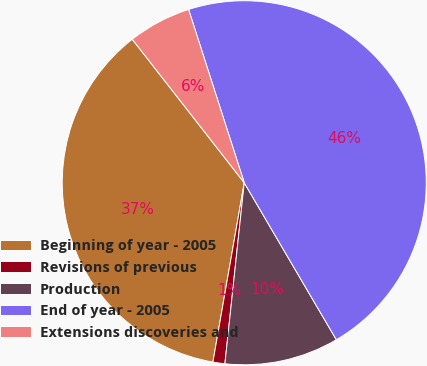<chart> <loc_0><loc_0><loc_500><loc_500><pie_chart><fcel>Beginning of year - 2005<fcel>Revisions of previous<fcel>Production<fcel>End of year - 2005<fcel>Extensions discoveries and<nl><fcel>36.7%<fcel>1.06%<fcel>10.14%<fcel>46.5%<fcel>5.6%<nl></chart> 